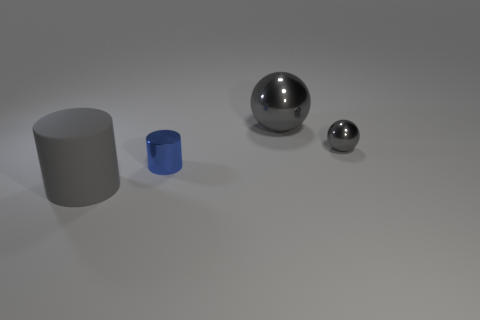The metal thing that is both left of the small gray sphere and behind the tiny cylinder is what color? gray 